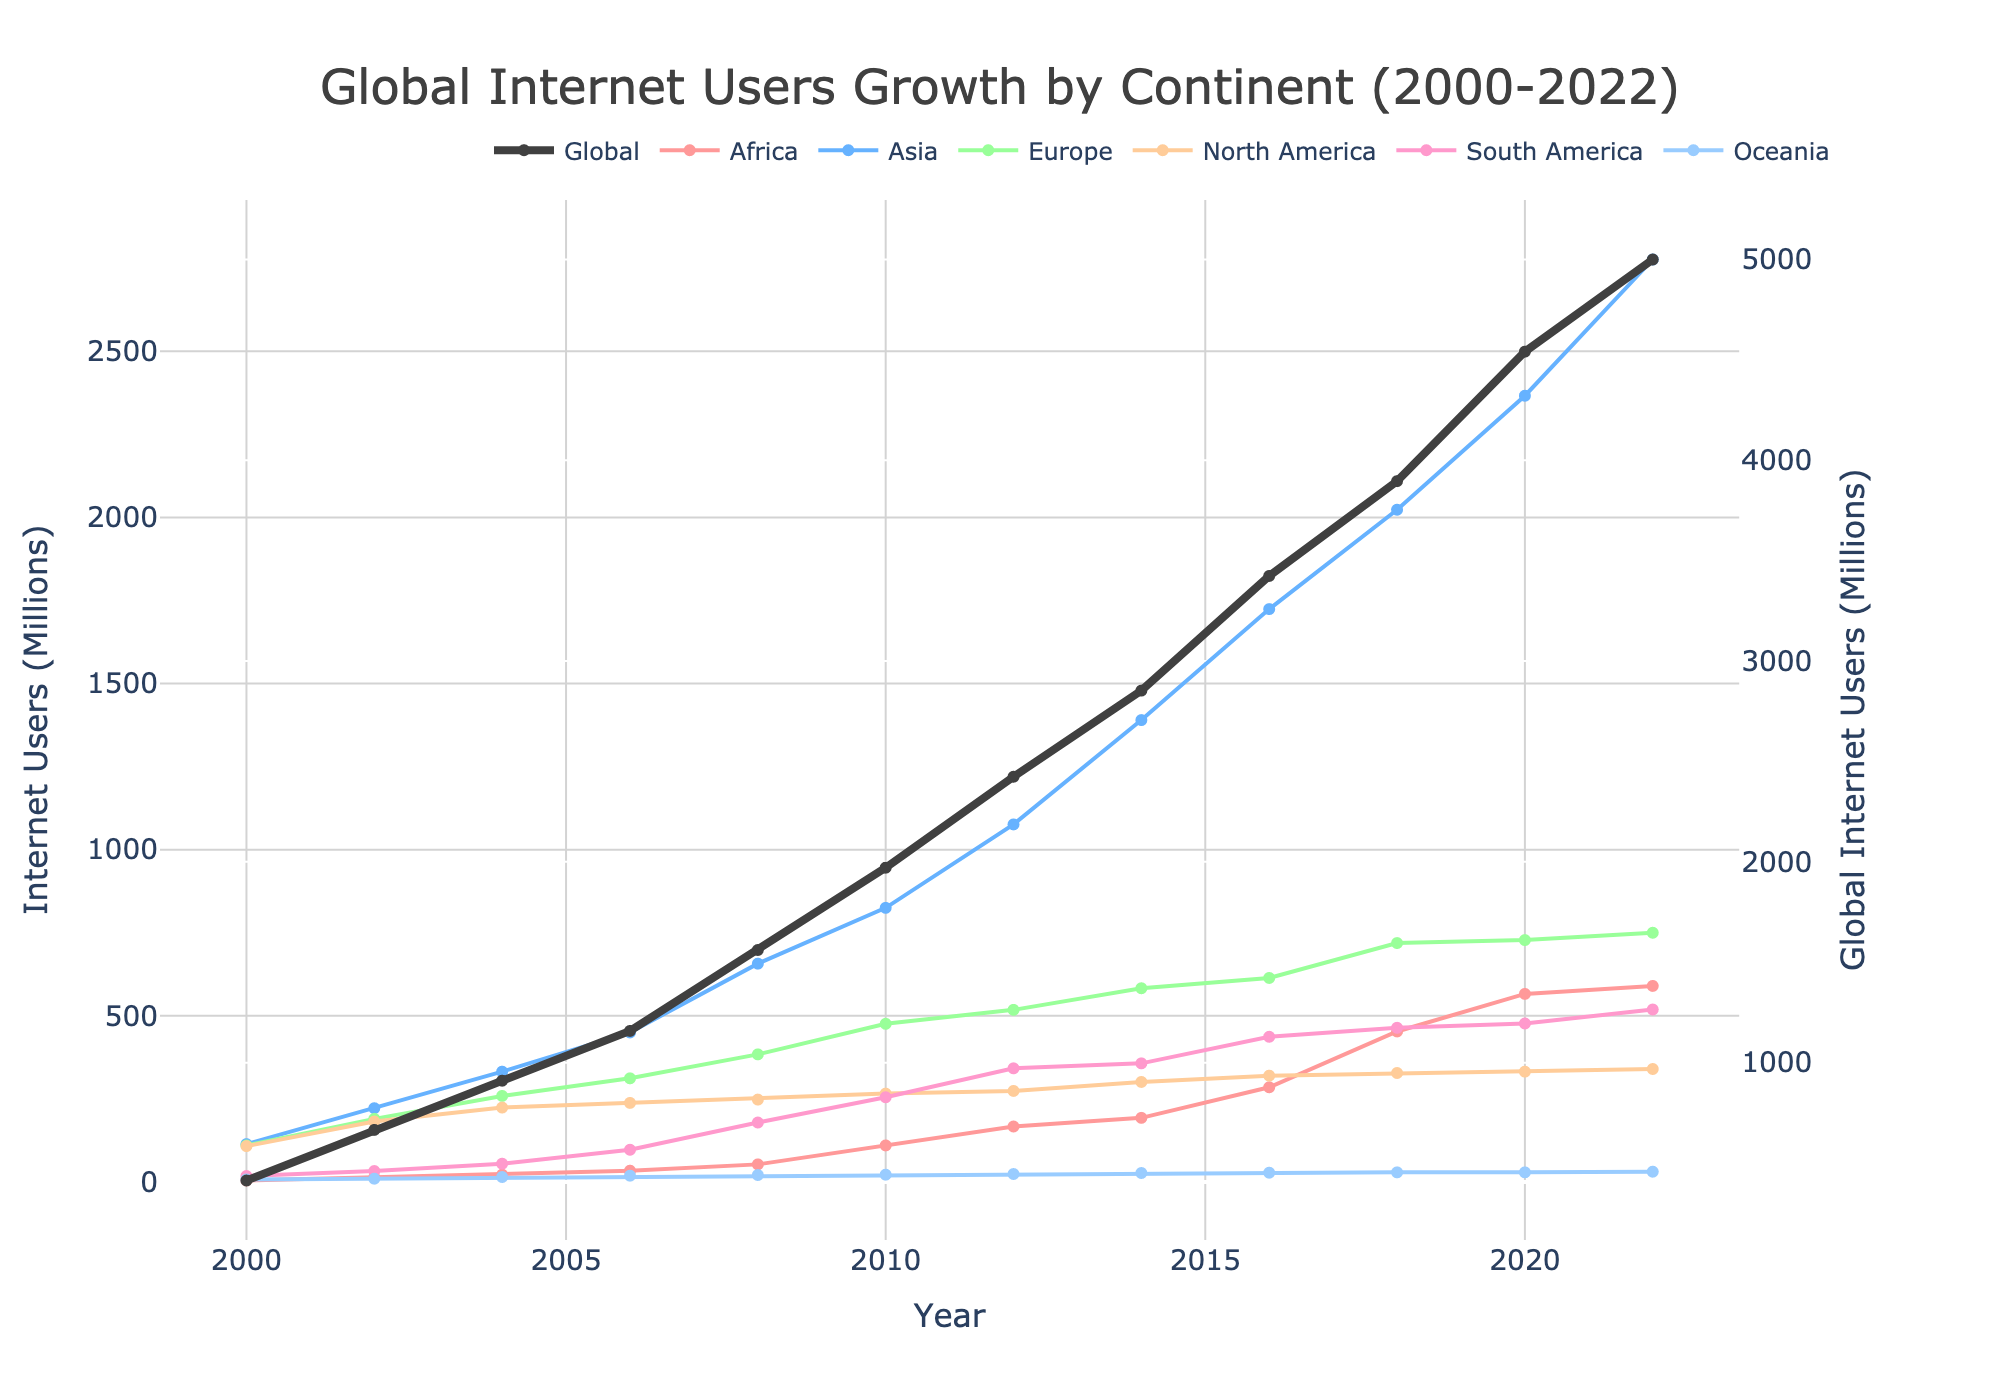How many total internet users were there globally in 2020? Look at the Global line on the secondary y-axis and find the value for the year 2020. It reads approximately 4541 million users.
Answer: 4541 million Which continent had the most significant increase in internet users between 2000 and 2022? Compare the values for each continent in 2000 and 2022. Africa went from 4.5 million to 590 million, making it the continent with the most significant increase.
Answer: Africa What was the approximate internet user growth in Asia from 2006 to 2018? Find the values for Asia in 2006 and 2018, which are 450 million and 2023 million respectively. Calculate the difference using 2023 - 450.
Answer: 1573 million Which continent had the least number of internet users in 2018? Look at the years for 2018 and compare the values for all continents. Oceania had the least with 29 million users.
Answer: Oceania Did Europe have more or fewer internet users than South America in 2014? Compare the values for Europe and South America for 2014. Europe had 583 million users while South America had 357 million users. Therefore, Europe had more.
Answer: More What's the combined number of internet users in North and South America in 2010? Look at the values for North America and South America in 2010, which are 266 million and 255 million respectively. Add these values together to get 266 + 255.
Answer: 521 million How did the number of internet users in Africa compare to Oceania in 2010? Look at the values for Africa and Oceania in 2010, which are 110 million and 22 million respectively. Africa had significantly more users.
Answer: Africa had more By how much did the number of global internet users increase between 2000 and 2022? Look at the Global line on the secondary y-axis for 2000 and 2022. The increase is calculated as 5000 million - 413 million.
Answer: 4587 million What can you infer about the trend of internet users in North America from 2000 to 2022? Observe the trend of the line representing North America from 2000 to 2022. The growth is relatively steady but slower compared to other continents.
Answer: Steady but slower growth 